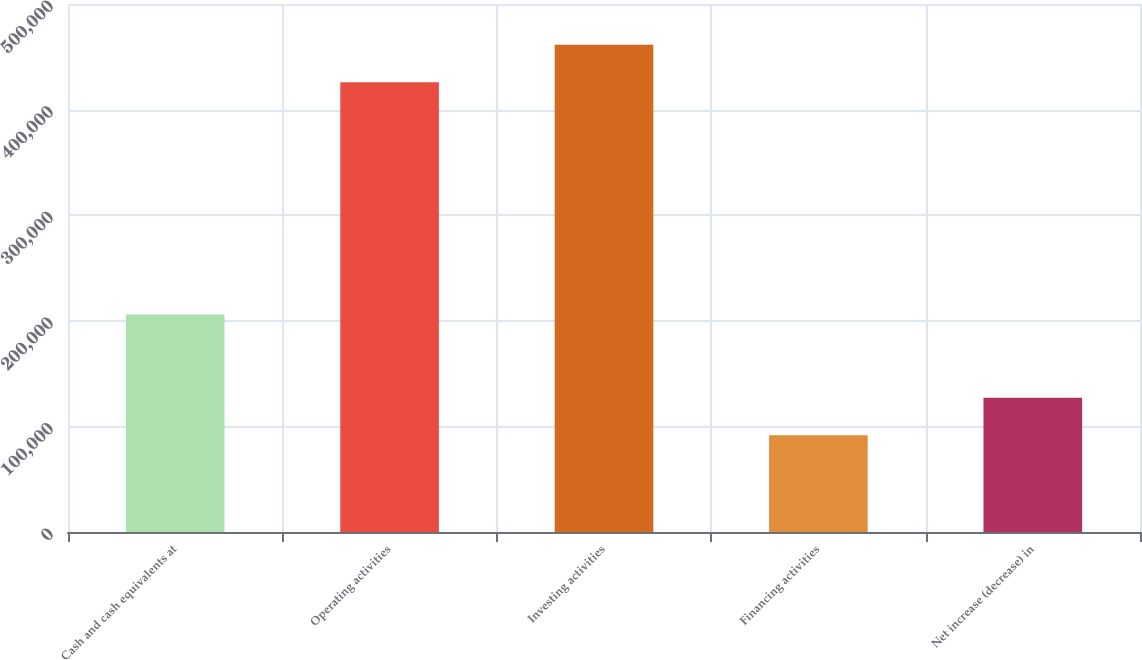Convert chart to OTSL. <chart><loc_0><loc_0><loc_500><loc_500><bar_chart><fcel>Cash and cash equivalents at<fcel>Operating activities<fcel>Investing activities<fcel>Financing activities<fcel>Net increase (decrease) in<nl><fcel>206030<fcel>425963<fcel>461457<fcel>91698<fcel>127192<nl></chart> 